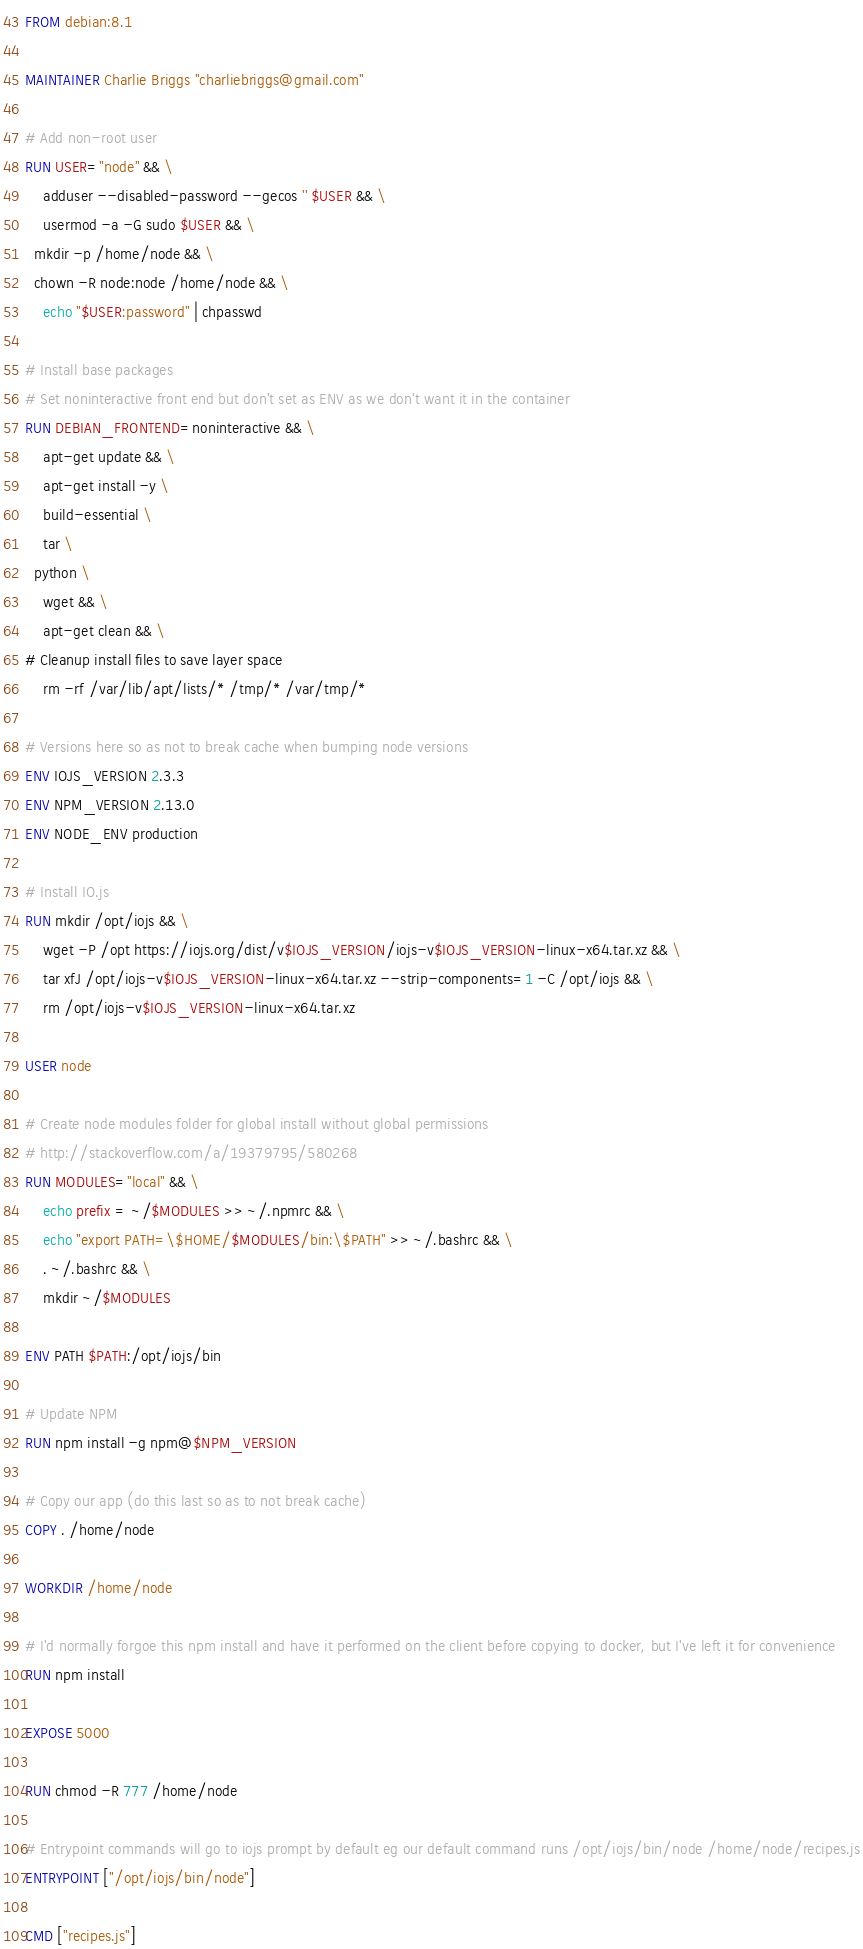Convert code to text. <code><loc_0><loc_0><loc_500><loc_500><_Dockerfile_>FROM debian:8.1

MAINTAINER Charlie Briggs "charliebriggs@gmail.com"

# Add non-root user
RUN USER="node" && \
	adduser --disabled-password --gecos '' $USER && \
	usermod -a -G sudo $USER && \
  mkdir -p /home/node && \
  chown -R node:node /home/node && \
	echo "$USER:password" | chpasswd

# Install base packages
# Set noninteractive front end but don't set as ENV as we don't want it in the container
RUN DEBIAN_FRONTEND=noninteractive && \
	apt-get update && \
	apt-get install -y \
	build-essential \
	tar \
  python \
	wget && \
	apt-get clean && \
# Cleanup install files to save layer space
	rm -rf /var/lib/apt/lists/* /tmp/* /var/tmp/*

# Versions here so as not to break cache when bumping node versions
ENV IOJS_VERSION 2.3.3
ENV NPM_VERSION 2.13.0
ENV NODE_ENV production

# Install IO.js
RUN mkdir /opt/iojs && \
	wget -P /opt https://iojs.org/dist/v$IOJS_VERSION/iojs-v$IOJS_VERSION-linux-x64.tar.xz && \
	tar xfJ /opt/iojs-v$IOJS_VERSION-linux-x64.tar.xz --strip-components=1 -C /opt/iojs && \
	rm /opt/iojs-v$IOJS_VERSION-linux-x64.tar.xz

USER node

# Create node modules folder for global install without global permissions
# http://stackoverflow.com/a/19379795/580268
RUN MODULES="local" && \
	echo prefix = ~/$MODULES >> ~/.npmrc && \
	echo "export PATH=\$HOME/$MODULES/bin:\$PATH" >> ~/.bashrc && \
	. ~/.bashrc && \
	mkdir ~/$MODULES

ENV PATH $PATH:/opt/iojs/bin

# Update NPM
RUN npm install -g npm@$NPM_VERSION

# Copy our app (do this last so as to not break cache)
COPY . /home/node

WORKDIR /home/node

# I'd normally forgoe this npm install and have it performed on the client before copying to docker, but I've left it for convenience
RUN npm install

EXPOSE 5000

RUN chmod -R 777 /home/node

# Entrypoint commands will go to iojs prompt by default eg our default command runs /opt/iojs/bin/node /home/node/recipes.js
ENTRYPOINT ["/opt/iojs/bin/node"]

CMD ["recipes.js"]
</code> 